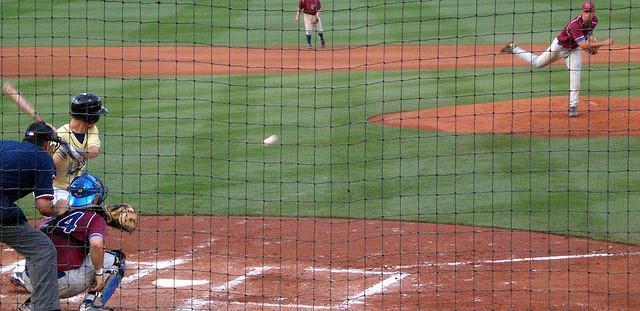How many people are there?
Give a very brief answer. 4. 